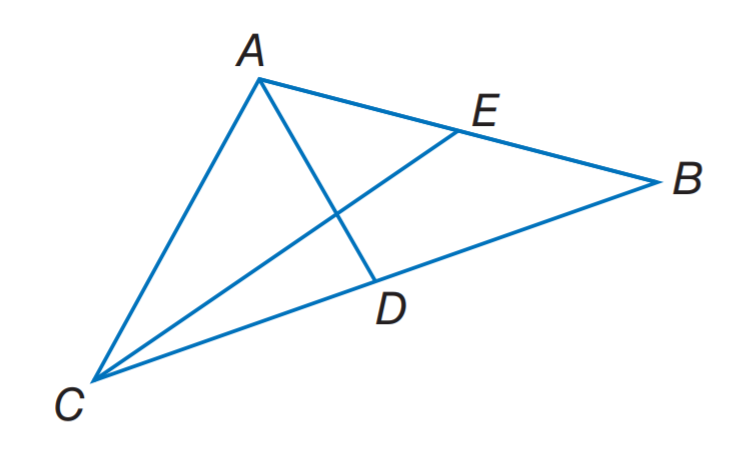Answer the mathemtical geometry problem and directly provide the correct option letter.
Question: Segments A D and C E are medians of \triangle A C B, A D \perp C E, A B = 10, and C E = 9. Find C A.
Choices: A: 2 \sqrt { 5 } B: \sqrt { 41 } C: \sqrt { 52 } D: \sqrt { 61 } C 